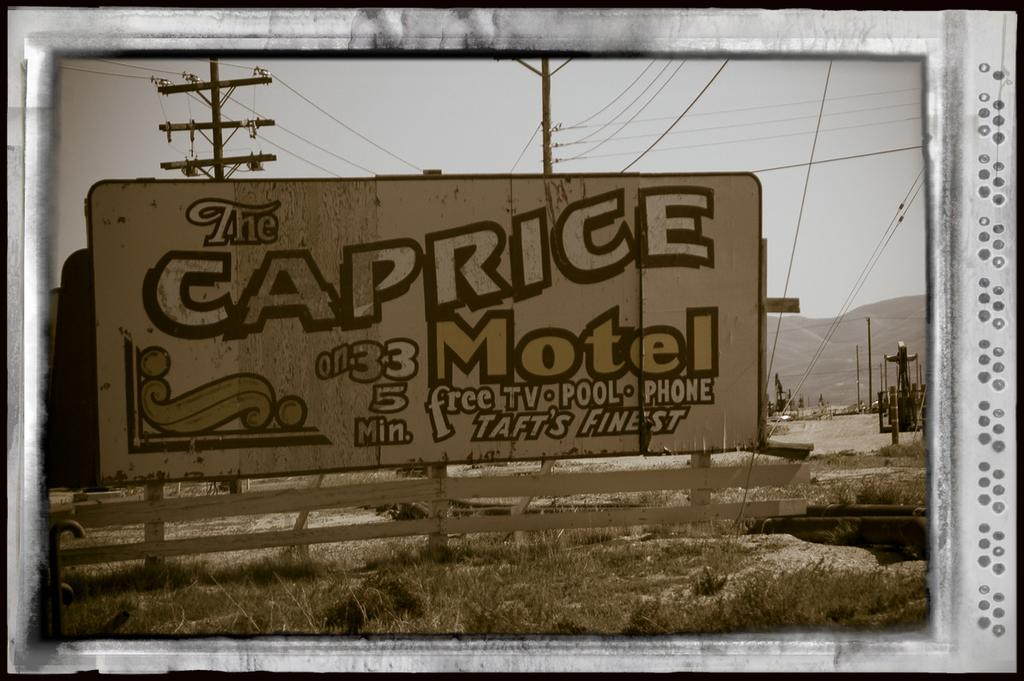What is the main object in the image? There is a board in the image. What other structures can be seen in the image? There is a fence, poles, and wires in the image. What type of terrain is visible in the image? There is grass and a mountain in the image. What is visible in the background of the image? The sky is visible in the background of the image. What type of detail can be seen on the beam in the image? There is no beam present in the image, so it is not possible to answer that question. 